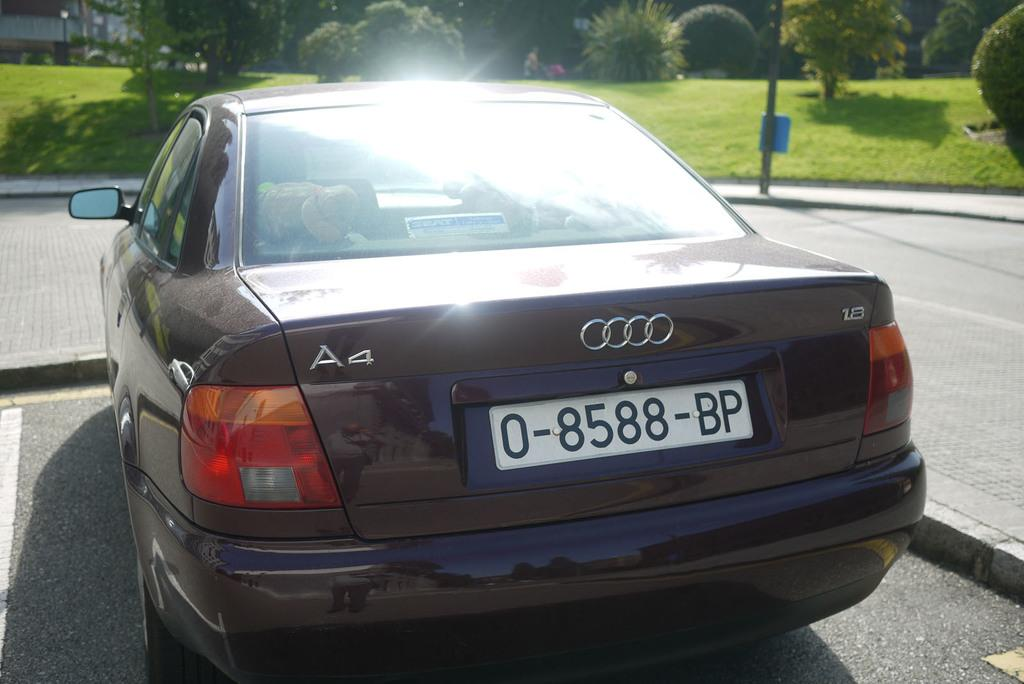<image>
Present a compact description of the photo's key features. A purple Audi A4 sits in an empty parking lot near a green field 